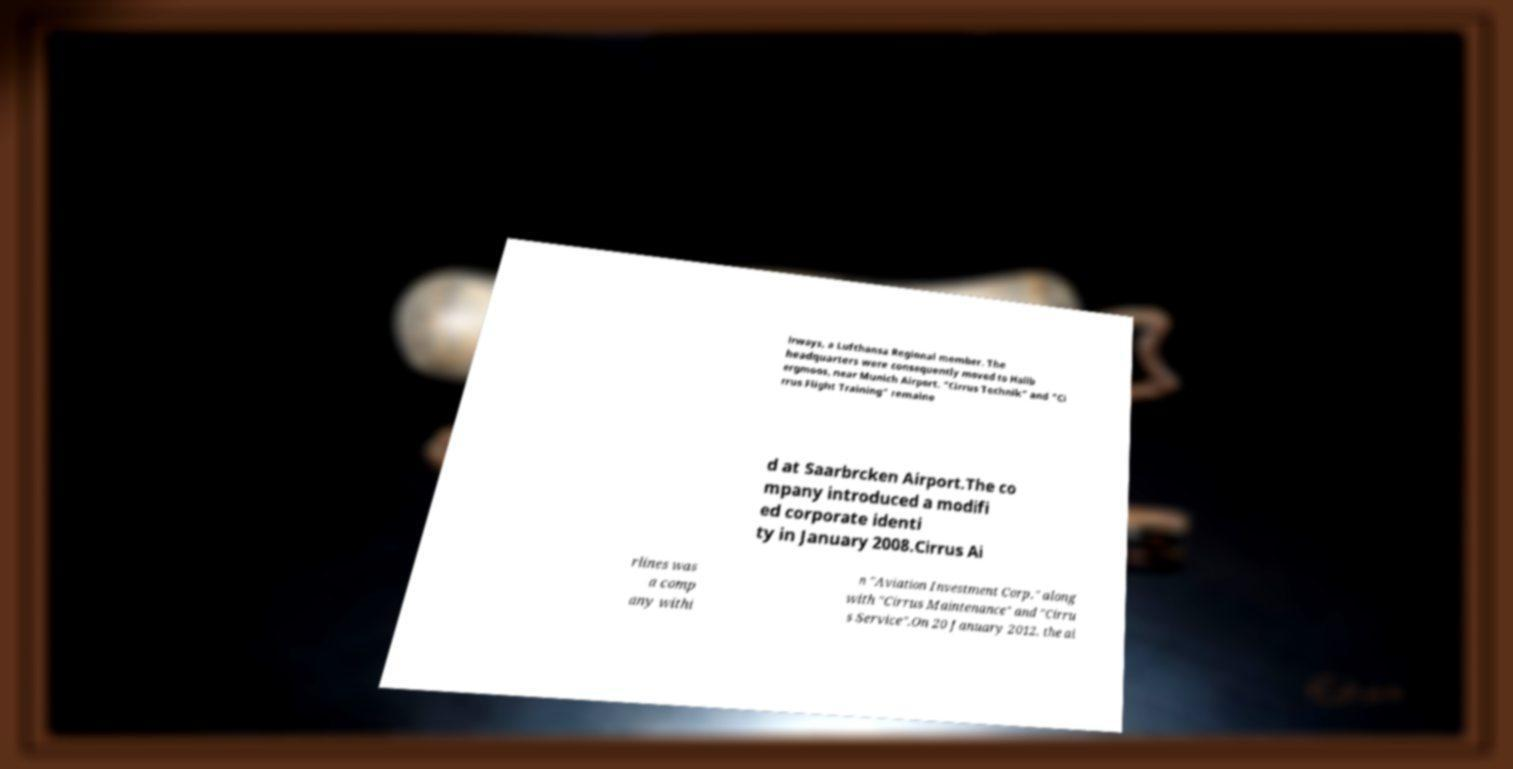What messages or text are displayed in this image? I need them in a readable, typed format. irways, a Lufthansa Regional member. The headquarters were consequently moved to Hallb ergmoos, near Munich Airport. "Cirrus Technik" and "Ci rrus Flight Training" remaine d at Saarbrcken Airport.The co mpany introduced a modifi ed corporate identi ty in January 2008.Cirrus Ai rlines was a comp any withi n "Aviation Investment Corp." along with "Cirrus Maintenance" and "Cirru s Service".On 20 January 2012, the ai 